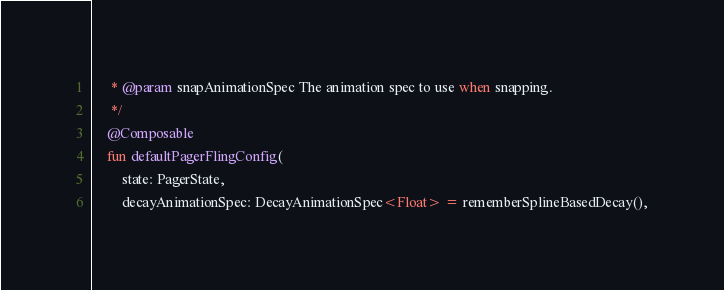<code> <loc_0><loc_0><loc_500><loc_500><_Kotlin_>     * @param snapAnimationSpec The animation spec to use when snapping.
     */
    @Composable
    fun defaultPagerFlingConfig(
        state: PagerState,
        decayAnimationSpec: DecayAnimationSpec<Float> = rememberSplineBasedDecay(),</code> 